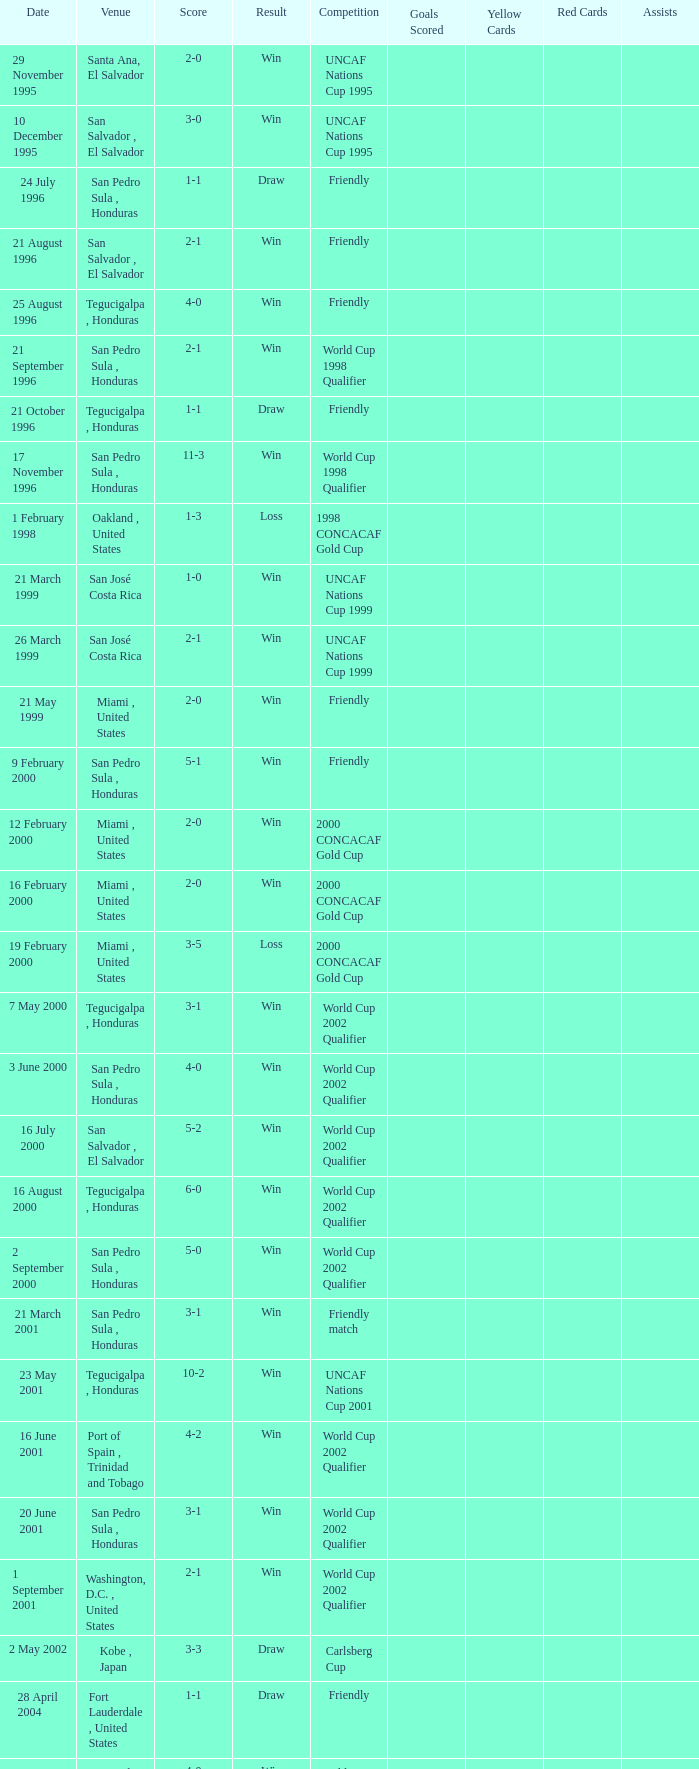What is the venue for the friendly competition and score of 4-0? Tegucigalpa , Honduras. 